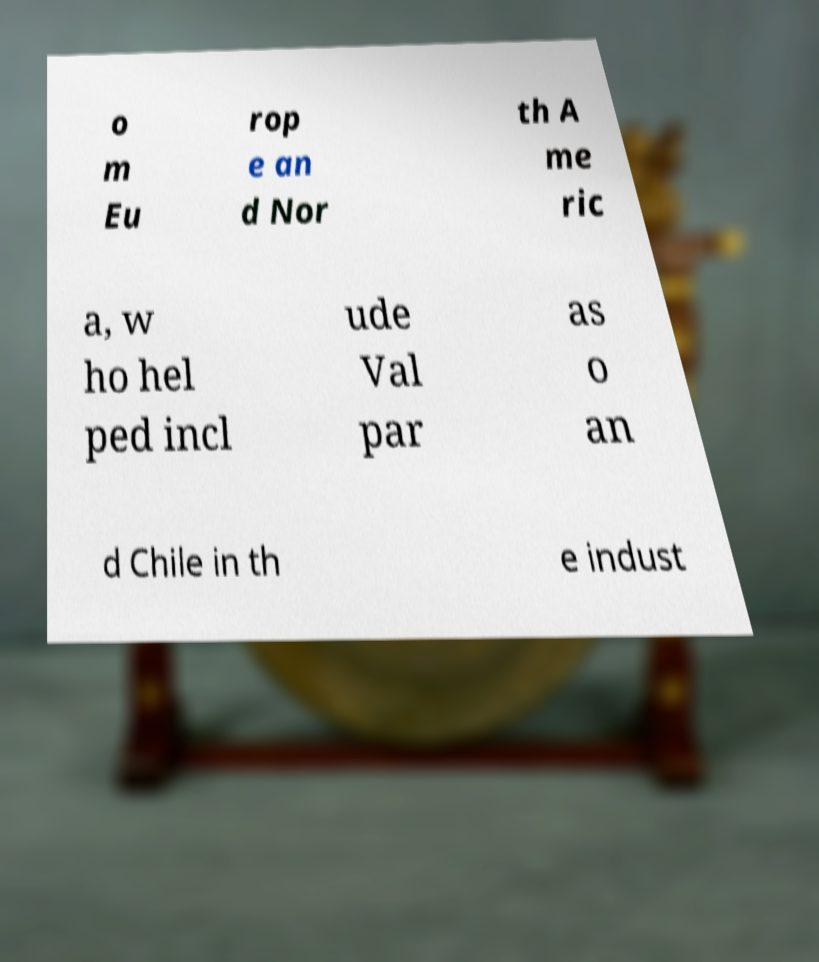I need the written content from this picture converted into text. Can you do that? o m Eu rop e an d Nor th A me ric a, w ho hel ped incl ude Val par as o an d Chile in th e indust 